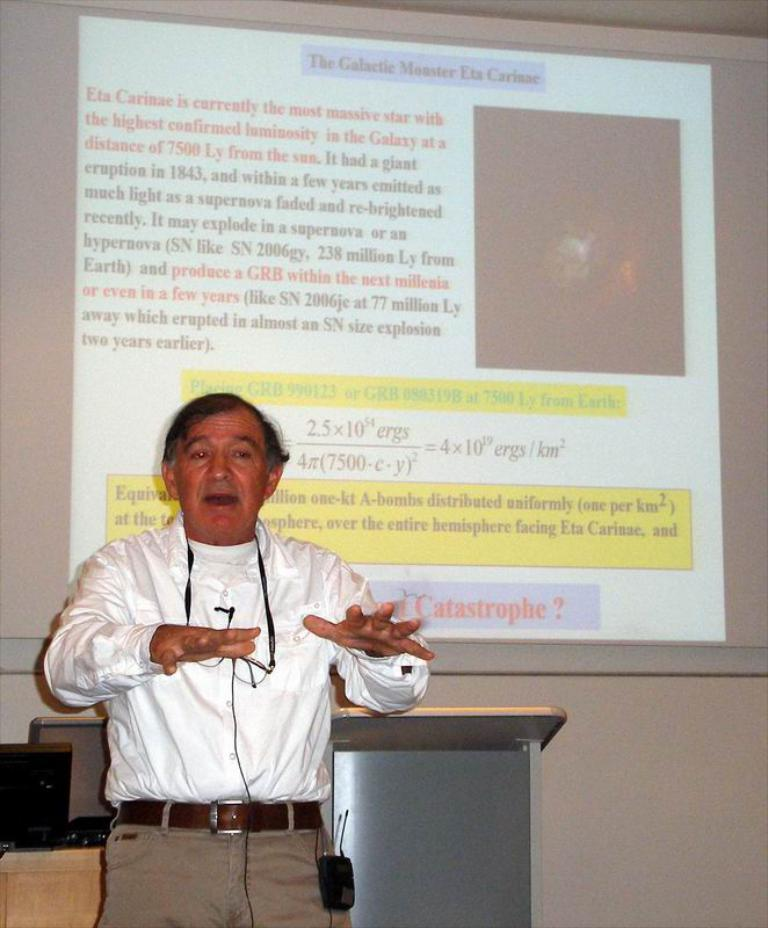Who is present in the image? There is a man in the image. Where is the man located in the image? The man is standing on the left side of the image. What can be seen in the background of the image? There is a projector screen in the background of the image. What is behind the man in the image? There is a desk behind the man. What book is the man holding in his tongue in the image? There is no book or tongue visible in the image; the man is simply standing on the left side of the image. 